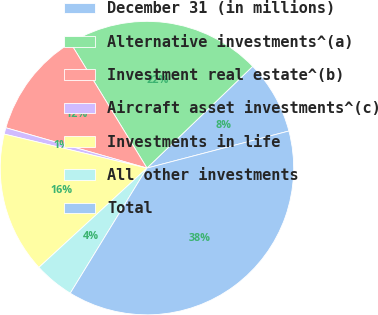Convert chart to OTSL. <chart><loc_0><loc_0><loc_500><loc_500><pie_chart><fcel>December 31 (in millions)<fcel>Alternative investments^(a)<fcel>Investment real estate^(b)<fcel>Aircraft asset investments^(c)<fcel>Investments in life<fcel>All other investments<fcel>Total<nl><fcel>8.13%<fcel>21.53%<fcel>11.84%<fcel>0.71%<fcel>15.55%<fcel>4.42%<fcel>37.81%<nl></chart> 